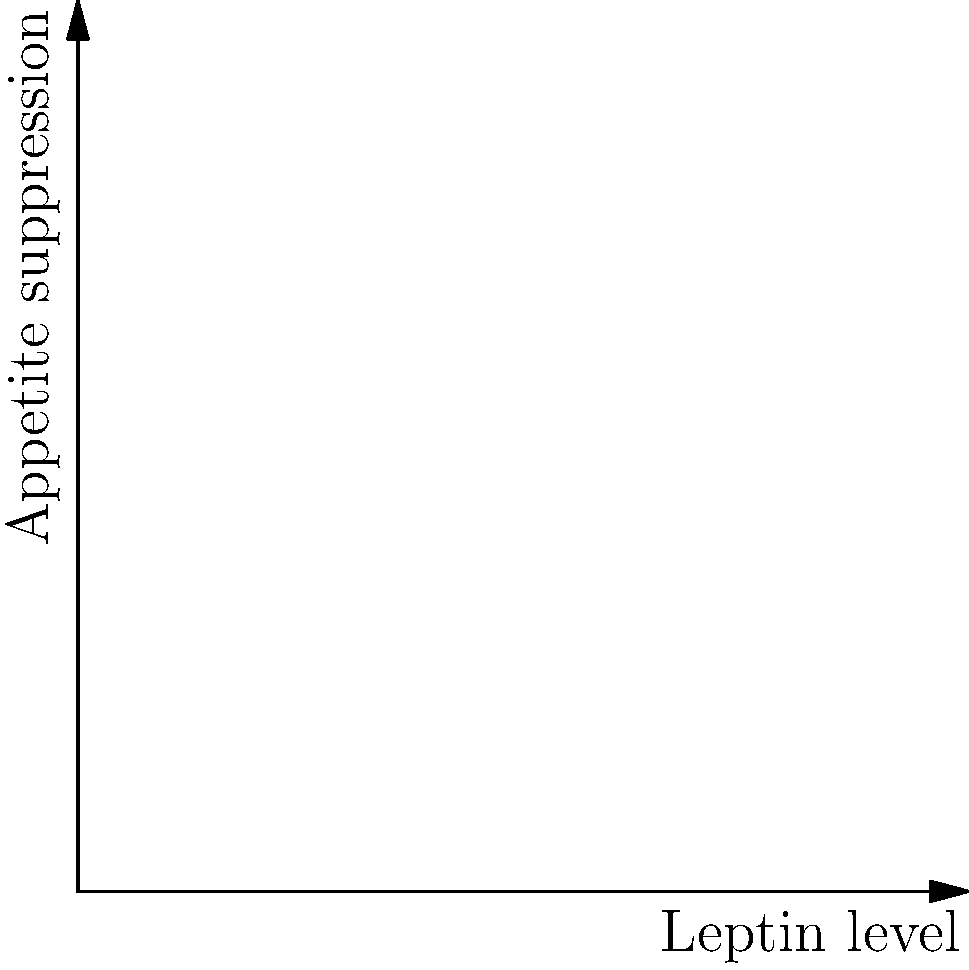The graph shows the relationship between leptin levels and appetite suppression in two different scenarios. Point A represents a normal response to leptin, while point B represents a state of leptin resistance. Given that leptin is a hormone produced by adipose tissue to regulate energy balance, explain why individuals with obesity might continue to experience hunger despite having high leptin levels. How does this relate to the concept of leptin resistance, and what implications does this have for weight regulation in obesity? To understand this graph and its implications for obesity, let's break it down step-by-step:

1. Leptin function: Leptin is a hormone produced by fat cells that normally helps regulate energy balance by inhibiting hunger.

2. Normal leptin response (blue curve):
   - As leptin levels increase, there's a sharp increase in appetite suppression.
   - Point A shows a strong appetite-suppressing effect at relatively low leptin levels.

3. Leptin resistance (red curve):
   - The curve is flatter, indicating a weaker response to leptin.
   - Point B shows much less appetite suppression despite higher leptin levels.

4. Leptin in obesity:
   - Obese individuals often have high leptin levels due to increased fat mass.
   - However, they don't experience the expected appetite suppression.

5. Leptin resistance mechanism:
   - Chronic exposure to high leptin levels can lead to decreased sensitivity of leptin receptors.
   - This is similar to insulin resistance in type 2 diabetes.

6. Implications for weight regulation:
   - Leptin resistance disrupts the body's ability to regulate energy balance.
   - Despite high leptin levels signaling adequate energy stores, the brain doesn't receive this message effectively.
   - This leads to continued hunger and overeating, making weight loss more challenging.

7. Treatment implications:
   - Simply administering more leptin is unlikely to be effective due to resistance.
   - Strategies to improve leptin sensitivity or bypass leptin resistance are areas of research for obesity treatment.

This explanation helps understand why obesity can be a self-perpetuating condition and why it's challenging to treat with simple calorie restriction alone.
Answer: Leptin resistance in obesity leads to reduced appetite suppression despite high leptin levels, disrupting normal weight regulation mechanisms. 